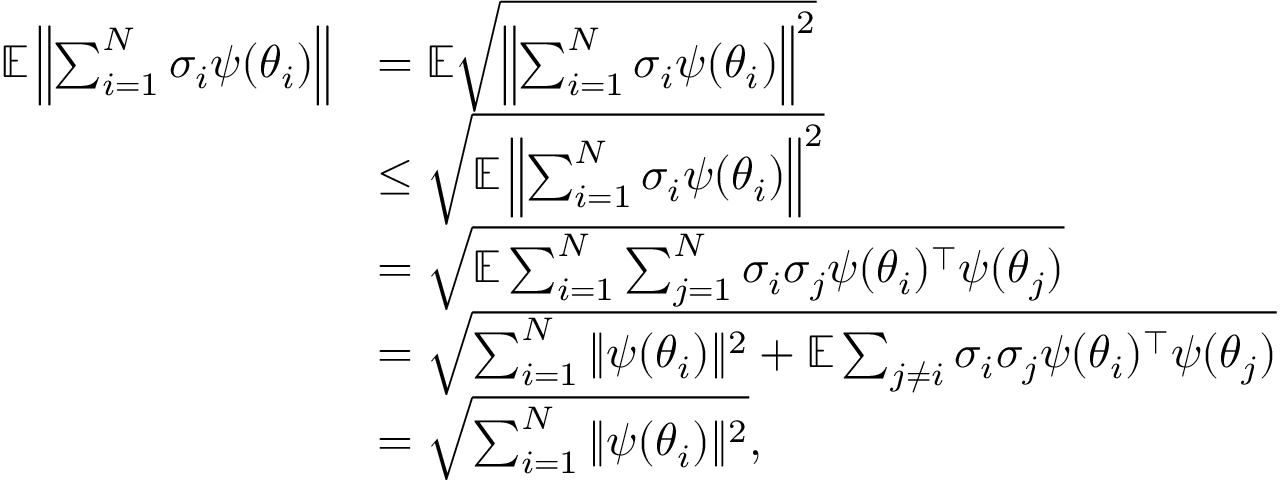<formula> <loc_0><loc_0><loc_500><loc_500>\begin{array} { r l } { \mathbb { E } \left \| \sum _ { i = 1 } ^ { N } \sigma _ { i } \psi ( \theta _ { i } ) \right \| } & { = \mathbb { E } \sqrt { \left \| \sum _ { i = 1 } ^ { N } \sigma _ { i } \psi ( \theta _ { i } ) \right \| ^ { 2 } } } \\ & { \leq \sqrt { \mathbb { E } \left \| \sum _ { i = 1 } ^ { N } \sigma _ { i } \psi ( \theta _ { i } ) \right \| ^ { 2 } } } \\ & { = \sqrt { \mathbb { E } \sum _ { i = 1 } ^ { N } \sum _ { j = 1 } ^ { N } \sigma _ { i } \sigma _ { j } \psi ( \theta _ { i } ) ^ { \top } \psi ( \theta _ { j } ) } } \\ & { = \sqrt { \sum _ { i = 1 } ^ { N } \| \psi ( \theta _ { i } ) \| ^ { 2 } + \mathbb { E } \sum _ { j \neq i } \sigma _ { i } \sigma _ { j } \psi ( \theta _ { i } ) ^ { \top } \psi ( \theta _ { j } ) } } \\ & { = \sqrt { \sum _ { i = 1 } ^ { N } \| \psi ( \theta _ { i } ) \| ^ { 2 } } , } \end{array}</formula> 